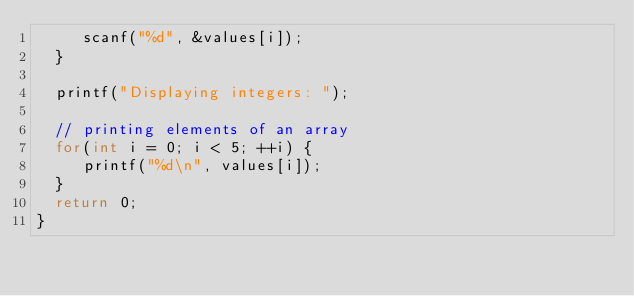Convert code to text. <code><loc_0><loc_0><loc_500><loc_500><_C_>     scanf("%d", &values[i]);
  }

  printf("Displaying integers: ");

  // printing elements of an array
  for(int i = 0; i < 5; ++i) {
     printf("%d\n", values[i]);
  }
  return 0;
}</code> 